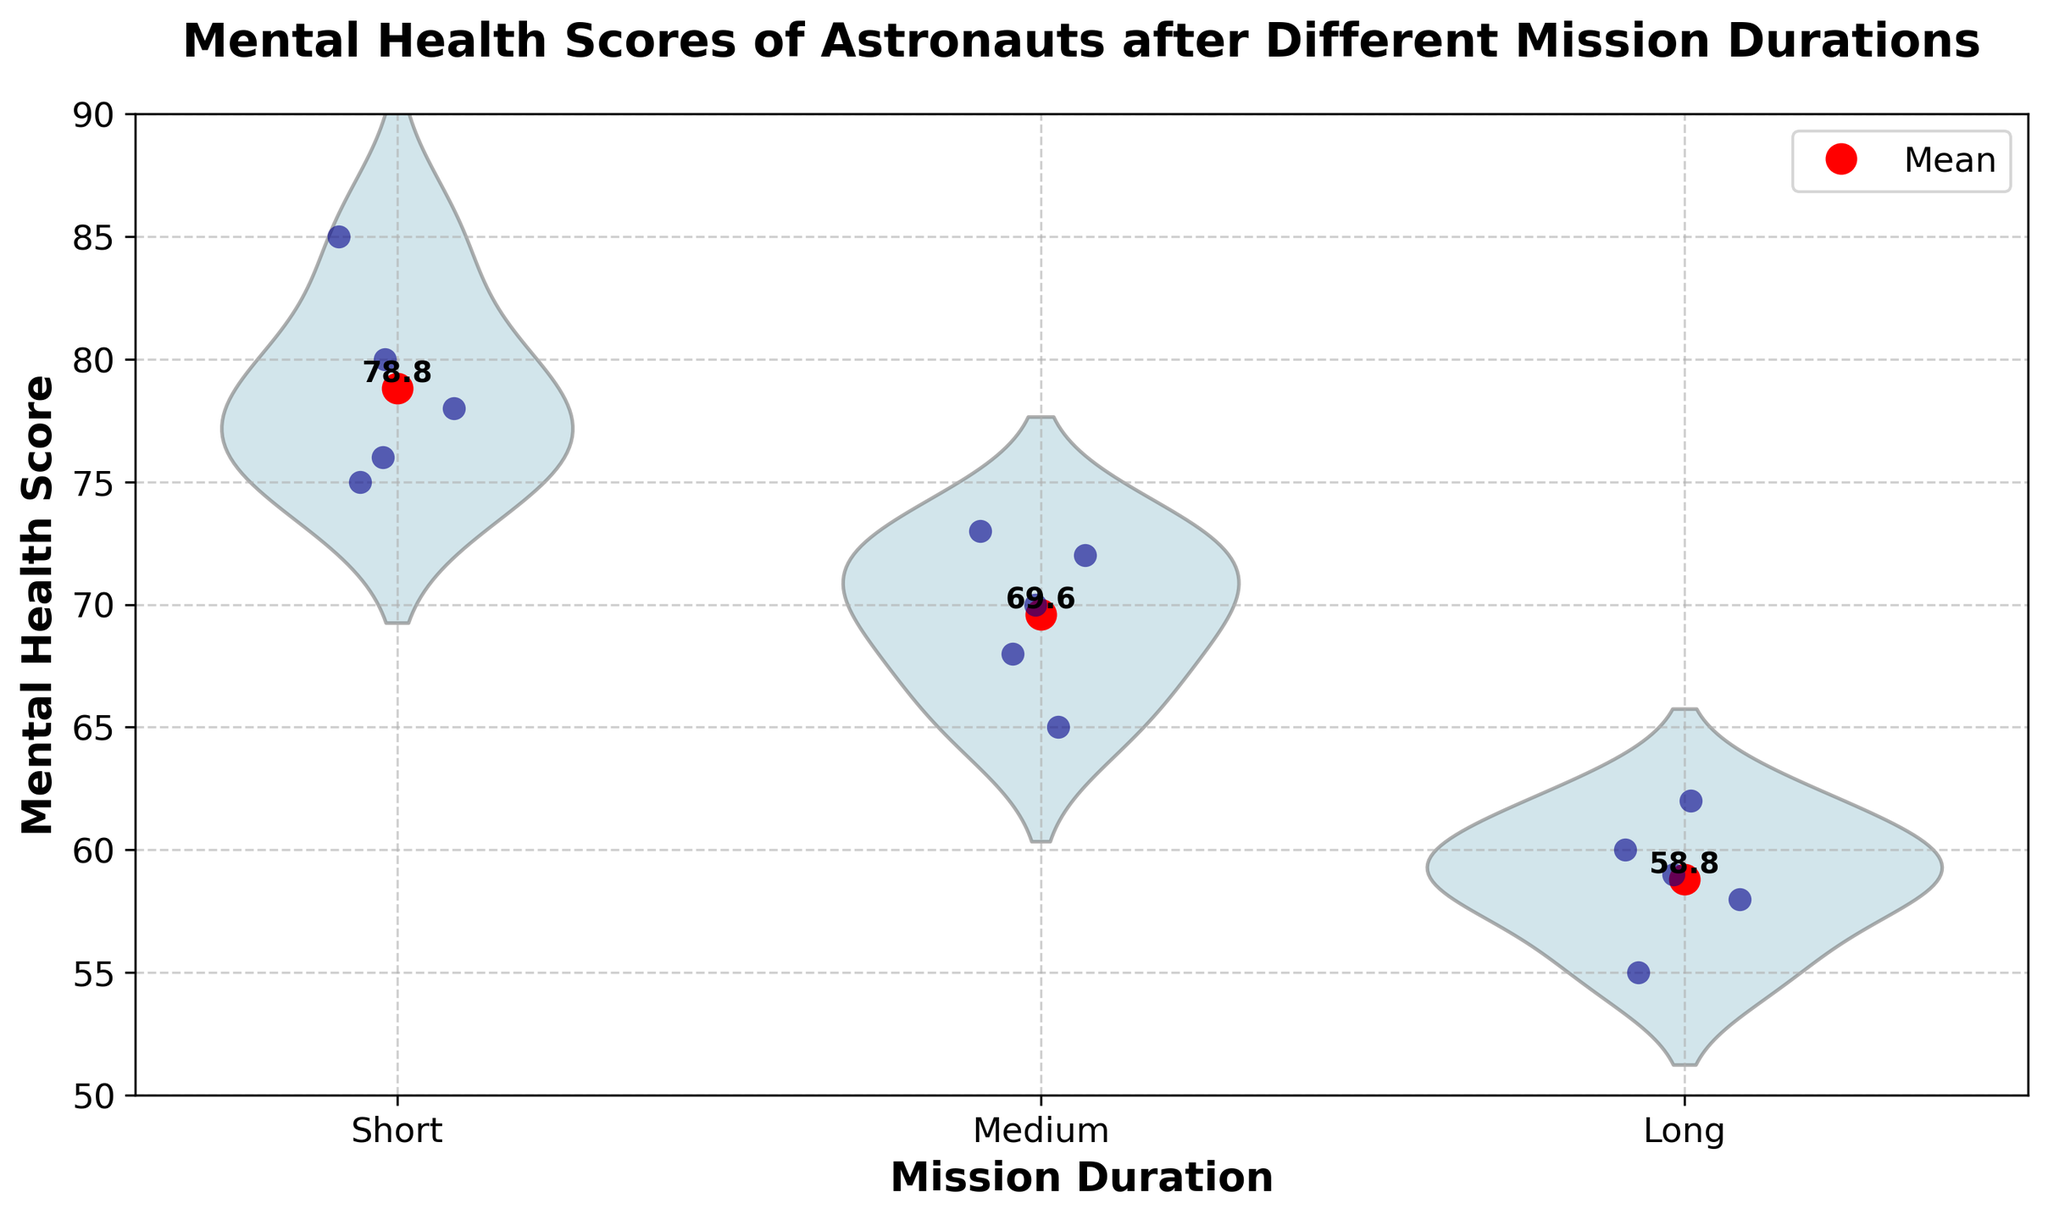What is the title of the plot? The title of the plot is typically found at the top center and describes the overall content and purpose of the graph. Here, it reads, "Mental Health Scores of Astronauts after Different Mission Durations".
Answer: Mental Health Scores of Astronauts after Different Mission Durations What is the y-axis label of the plot? The y-axis label is positioned vertically along the left side of the plot and indicates what is being measured. In this case, the y-axis is labeled "Mental Health Score".
Answer: Mental Health Score Which mission duration category has the highest mean mental health score? The mean mental health scores are marked by red dots and annotated. The highest red dot is for the "Short" mission duration category.
Answer: Short How many astronauts' mental health scores are displayed for each mission duration? The jittered points represent individual scores, and by counting these, we find 5 scores for each of the "Short", "Medium", and "Long" mission durations.
Answer: 5 What is the mean mental health score for the "Medium" mission duration? The plot shows red dots for mean values, and the annotated text next to these dots gives the value. The mean score for "Medium" duration is marked as 69.6.
Answer: 69.6 Compare the spread of mental health scores across different mission durations. Which duration shows the widest spread? The violin plots show the distribution of scores, with wider sections indicating more spread. The "Long" mission duration has the widest spread, suggesting more variability in mental health scores.
Answer: Long Which mission duration category has the lowest individual mental health score, and what is that score? The lowest individual score is seen in the jittered points for the "Long" mission duration, which is 55.
Answer: Long, 55 What can you infer about the relationship between mission duration and mental health outcomes? The mean mental health scores decrease as mission duration increases, with "Short" missions having the highest mean and "Long" missions the lowest. This suggests a potential negative impact of longer missions on mental health.
Answer: Longer missions may negatively impact mental health Is there any overlap in the mental health score ranges between different mission durations? The overlapping areas in the violin plots indicate shared score ranges. We observe overlaps particularly between "Medium" and "Long" durations, and less overlap between "Short" and other durations.
Answer: Yes What is the range of mental health scores for the "Short" mission duration? The violin plot for "Short" duration extends from the lowest jittered point (75) to the highest one (85), indicating a range from 75 to 85.
Answer: 75 to 85 